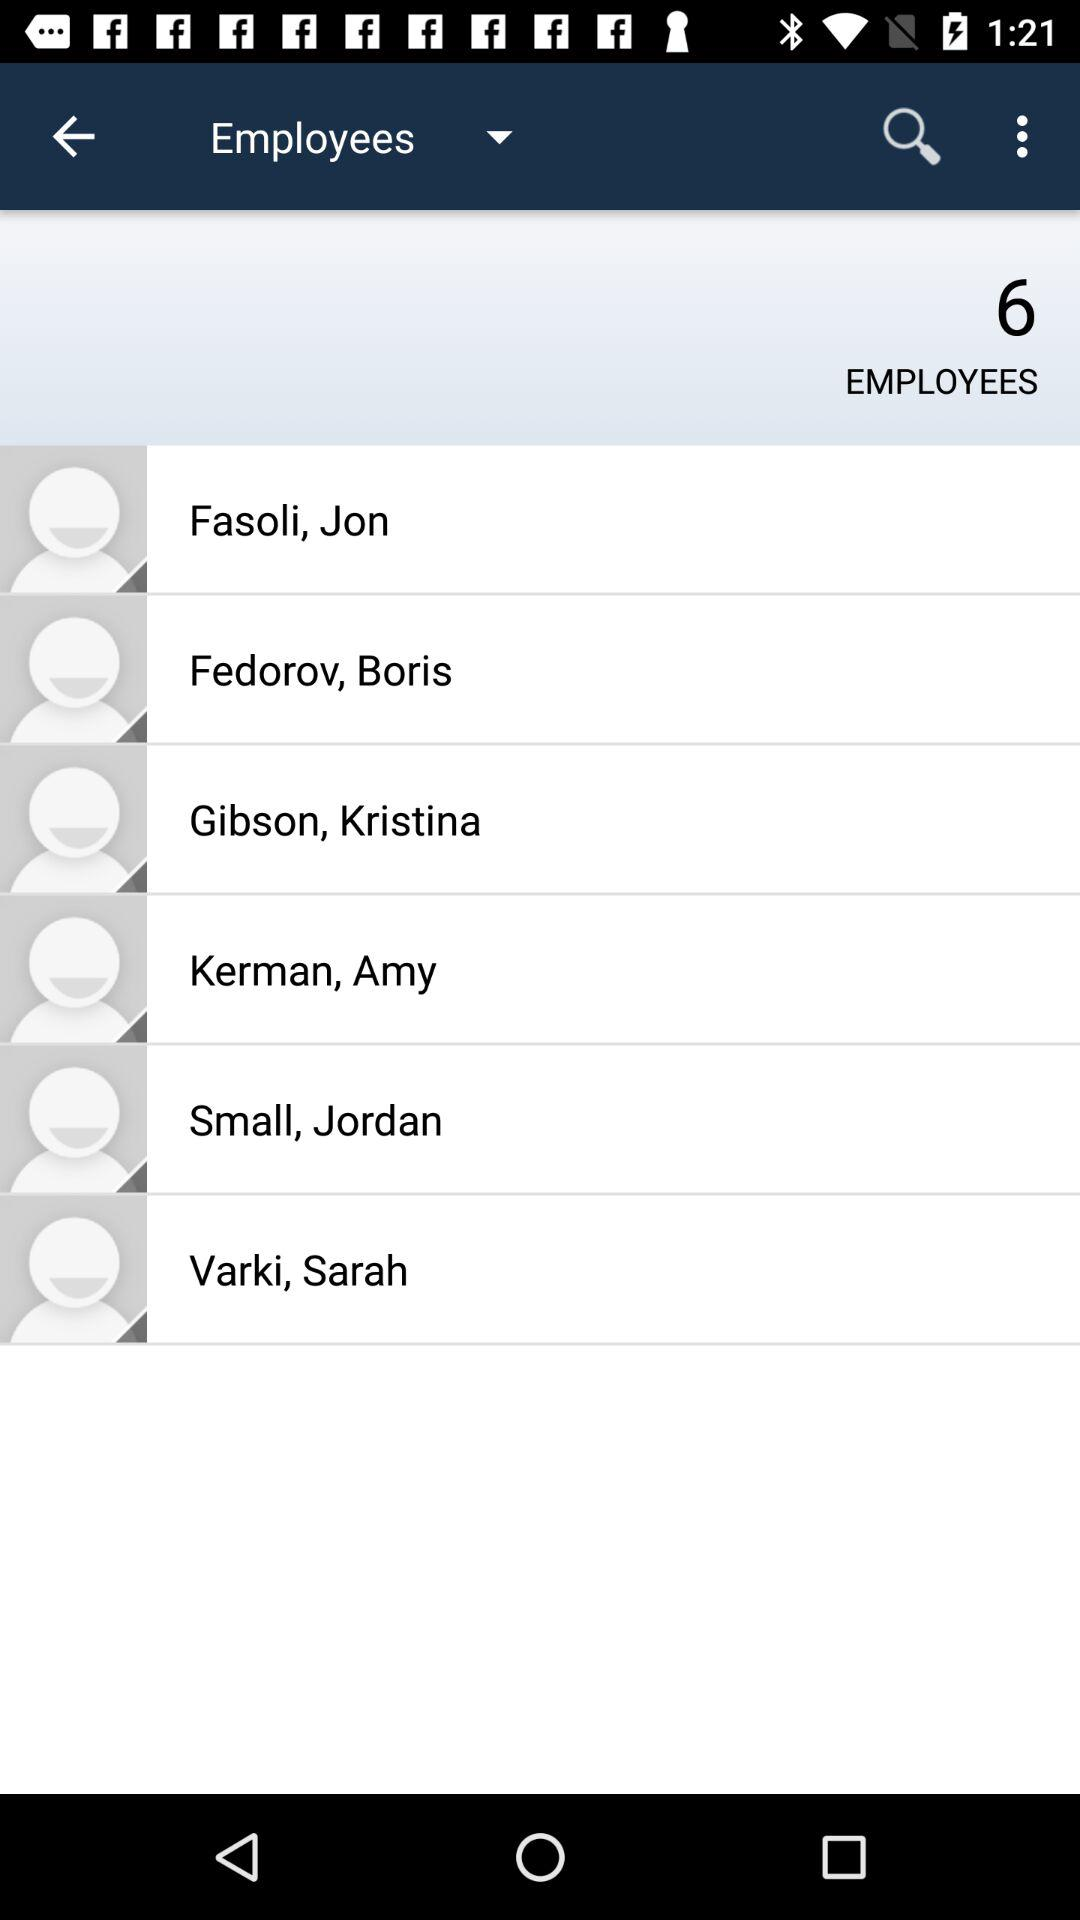How many employees are there? There are 6 employees. 